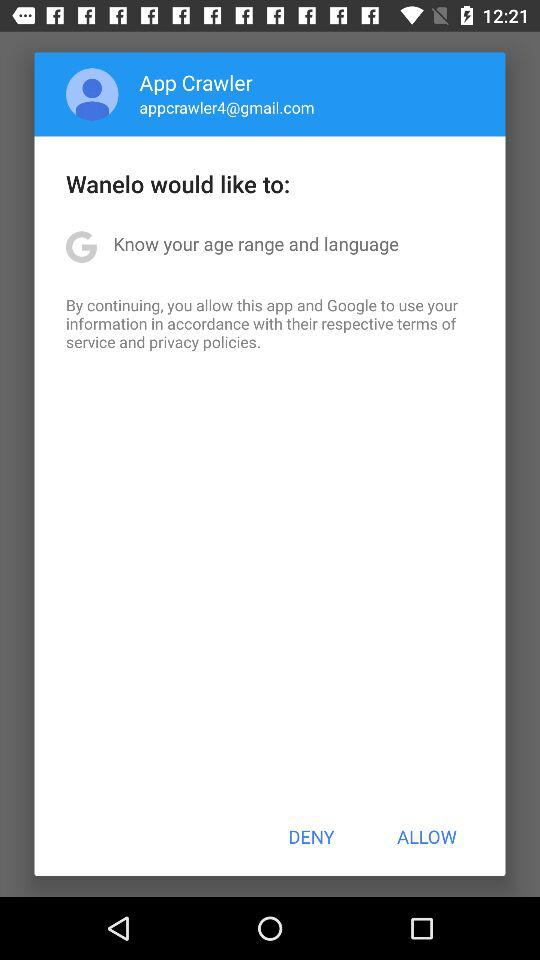What is the profile name? The profile name is App Crawler. 